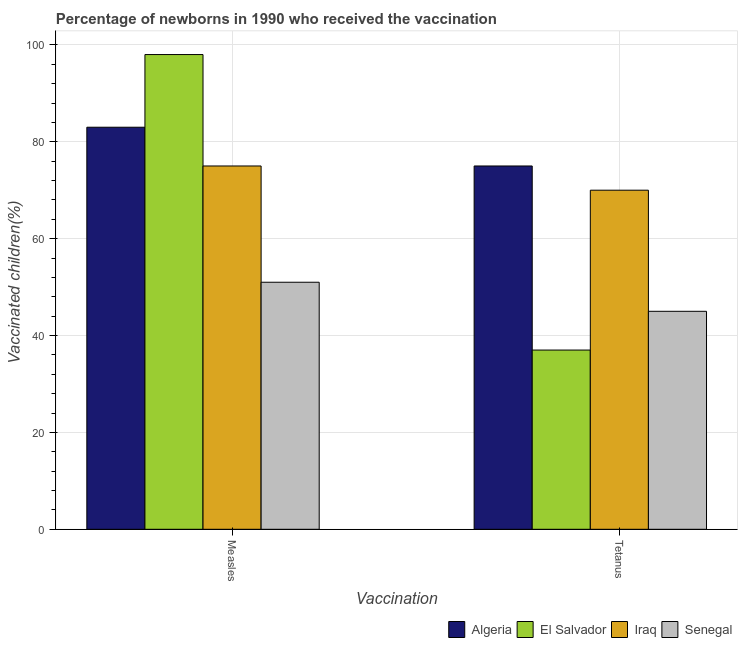How many groups of bars are there?
Your response must be concise. 2. How many bars are there on the 1st tick from the right?
Your answer should be very brief. 4. What is the label of the 1st group of bars from the left?
Ensure brevity in your answer.  Measles. What is the percentage of newborns who received vaccination for tetanus in Senegal?
Make the answer very short. 45. Across all countries, what is the maximum percentage of newborns who received vaccination for measles?
Ensure brevity in your answer.  98. Across all countries, what is the minimum percentage of newborns who received vaccination for measles?
Give a very brief answer. 51. In which country was the percentage of newborns who received vaccination for measles maximum?
Keep it short and to the point. El Salvador. In which country was the percentage of newborns who received vaccination for tetanus minimum?
Offer a terse response. El Salvador. What is the total percentage of newborns who received vaccination for measles in the graph?
Provide a short and direct response. 307. What is the difference between the percentage of newborns who received vaccination for tetanus in Algeria and that in El Salvador?
Your answer should be compact. 38. What is the difference between the percentage of newborns who received vaccination for tetanus in El Salvador and the percentage of newborns who received vaccination for measles in Algeria?
Give a very brief answer. -46. What is the average percentage of newborns who received vaccination for measles per country?
Ensure brevity in your answer.  76.75. What is the difference between the percentage of newborns who received vaccination for tetanus and percentage of newborns who received vaccination for measles in Algeria?
Give a very brief answer. -8. In how many countries, is the percentage of newborns who received vaccination for tetanus greater than 60 %?
Your answer should be compact. 2. What is the ratio of the percentage of newborns who received vaccination for measles in Iraq to that in El Salvador?
Keep it short and to the point. 0.77. What does the 4th bar from the left in Measles represents?
Keep it short and to the point. Senegal. What does the 3rd bar from the right in Tetanus represents?
Ensure brevity in your answer.  El Salvador. Are all the bars in the graph horizontal?
Offer a terse response. No. How many countries are there in the graph?
Your answer should be compact. 4. What is the difference between two consecutive major ticks on the Y-axis?
Your answer should be compact. 20. Does the graph contain any zero values?
Give a very brief answer. No. Where does the legend appear in the graph?
Give a very brief answer. Bottom right. How many legend labels are there?
Ensure brevity in your answer.  4. What is the title of the graph?
Give a very brief answer. Percentage of newborns in 1990 who received the vaccination. Does "Tanzania" appear as one of the legend labels in the graph?
Your answer should be very brief. No. What is the label or title of the X-axis?
Offer a terse response. Vaccination. What is the label or title of the Y-axis?
Make the answer very short. Vaccinated children(%)
. What is the Vaccinated children(%)
 in El Salvador in Measles?
Your response must be concise. 98. What is the Vaccinated children(%)
 in Iraq in Measles?
Ensure brevity in your answer.  75. What is the Vaccinated children(%)
 in El Salvador in Tetanus?
Offer a terse response. 37. What is the Vaccinated children(%)
 in Iraq in Tetanus?
Your response must be concise. 70. What is the Vaccinated children(%)
 of Senegal in Tetanus?
Keep it short and to the point. 45. Across all Vaccination, what is the maximum Vaccinated children(%)
 in Algeria?
Your answer should be compact. 83. Across all Vaccination, what is the maximum Vaccinated children(%)
 in El Salvador?
Ensure brevity in your answer.  98. Across all Vaccination, what is the maximum Vaccinated children(%)
 of Iraq?
Your answer should be compact. 75. Across all Vaccination, what is the maximum Vaccinated children(%)
 in Senegal?
Make the answer very short. 51. Across all Vaccination, what is the minimum Vaccinated children(%)
 in Algeria?
Provide a succinct answer. 75. Across all Vaccination, what is the minimum Vaccinated children(%)
 in El Salvador?
Keep it short and to the point. 37. Across all Vaccination, what is the minimum Vaccinated children(%)
 of Iraq?
Offer a very short reply. 70. Across all Vaccination, what is the minimum Vaccinated children(%)
 of Senegal?
Make the answer very short. 45. What is the total Vaccinated children(%)
 of Algeria in the graph?
Keep it short and to the point. 158. What is the total Vaccinated children(%)
 of El Salvador in the graph?
Your answer should be compact. 135. What is the total Vaccinated children(%)
 in Iraq in the graph?
Provide a short and direct response. 145. What is the total Vaccinated children(%)
 in Senegal in the graph?
Your answer should be very brief. 96. What is the difference between the Vaccinated children(%)
 in Algeria in Measles and that in Tetanus?
Offer a terse response. 8. What is the difference between the Vaccinated children(%)
 in Senegal in Measles and that in Tetanus?
Your response must be concise. 6. What is the difference between the Vaccinated children(%)
 of Algeria in Measles and the Vaccinated children(%)
 of Iraq in Tetanus?
Keep it short and to the point. 13. What is the difference between the Vaccinated children(%)
 of Algeria in Measles and the Vaccinated children(%)
 of Senegal in Tetanus?
Give a very brief answer. 38. What is the difference between the Vaccinated children(%)
 in Iraq in Measles and the Vaccinated children(%)
 in Senegal in Tetanus?
Provide a short and direct response. 30. What is the average Vaccinated children(%)
 of Algeria per Vaccination?
Keep it short and to the point. 79. What is the average Vaccinated children(%)
 in El Salvador per Vaccination?
Offer a very short reply. 67.5. What is the average Vaccinated children(%)
 in Iraq per Vaccination?
Offer a terse response. 72.5. What is the average Vaccinated children(%)
 of Senegal per Vaccination?
Give a very brief answer. 48. What is the difference between the Vaccinated children(%)
 of Algeria and Vaccinated children(%)
 of Iraq in Measles?
Your answer should be very brief. 8. What is the difference between the Vaccinated children(%)
 of El Salvador and Vaccinated children(%)
 of Iraq in Measles?
Your response must be concise. 23. What is the difference between the Vaccinated children(%)
 in El Salvador and Vaccinated children(%)
 in Senegal in Measles?
Keep it short and to the point. 47. What is the difference between the Vaccinated children(%)
 in Algeria and Vaccinated children(%)
 in Iraq in Tetanus?
Your answer should be very brief. 5. What is the difference between the Vaccinated children(%)
 of Algeria and Vaccinated children(%)
 of Senegal in Tetanus?
Provide a succinct answer. 30. What is the difference between the Vaccinated children(%)
 of El Salvador and Vaccinated children(%)
 of Iraq in Tetanus?
Ensure brevity in your answer.  -33. What is the difference between the Vaccinated children(%)
 in El Salvador and Vaccinated children(%)
 in Senegal in Tetanus?
Offer a terse response. -8. What is the difference between the Vaccinated children(%)
 in Iraq and Vaccinated children(%)
 in Senegal in Tetanus?
Your answer should be very brief. 25. What is the ratio of the Vaccinated children(%)
 in Algeria in Measles to that in Tetanus?
Your answer should be very brief. 1.11. What is the ratio of the Vaccinated children(%)
 of El Salvador in Measles to that in Tetanus?
Offer a terse response. 2.65. What is the ratio of the Vaccinated children(%)
 in Iraq in Measles to that in Tetanus?
Make the answer very short. 1.07. What is the ratio of the Vaccinated children(%)
 of Senegal in Measles to that in Tetanus?
Give a very brief answer. 1.13. What is the difference between the highest and the second highest Vaccinated children(%)
 of Algeria?
Your response must be concise. 8. What is the difference between the highest and the second highest Vaccinated children(%)
 of El Salvador?
Keep it short and to the point. 61. What is the difference between the highest and the lowest Vaccinated children(%)
 of El Salvador?
Offer a very short reply. 61. 